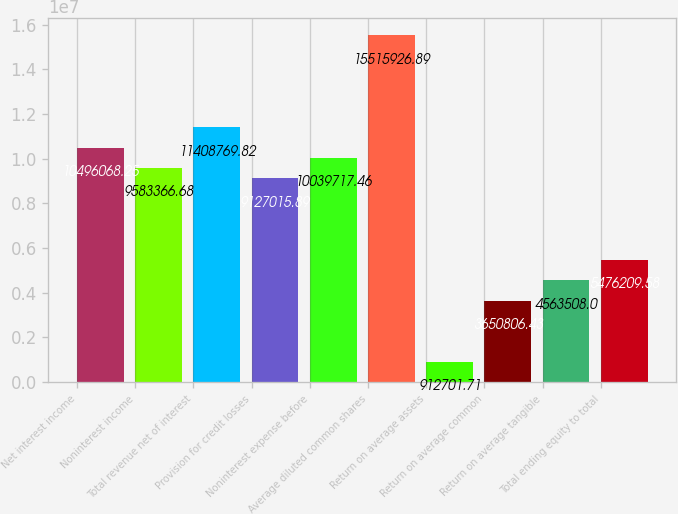Convert chart. <chart><loc_0><loc_0><loc_500><loc_500><bar_chart><fcel>Net interest income<fcel>Noninterest income<fcel>Total revenue net of interest<fcel>Provision for credit losses<fcel>Noninterest expense before<fcel>Average diluted common shares<fcel>Return on average assets<fcel>Return on average common<fcel>Return on average tangible<fcel>Total ending equity to total<nl><fcel>1.04961e+07<fcel>9.58337e+06<fcel>1.14088e+07<fcel>9.12702e+06<fcel>1.00397e+07<fcel>1.55159e+07<fcel>912702<fcel>3.65081e+06<fcel>4.56351e+06<fcel>5.47621e+06<nl></chart> 